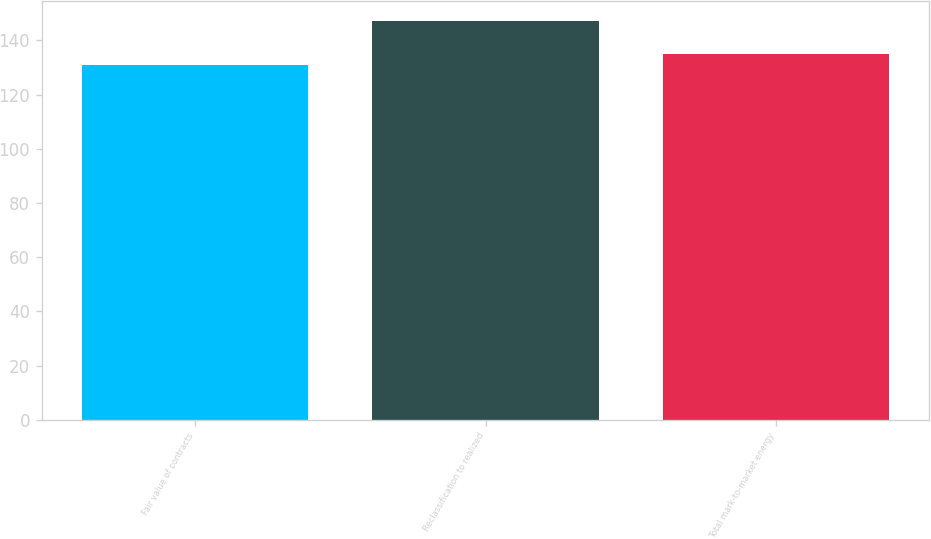<chart> <loc_0><loc_0><loc_500><loc_500><bar_chart><fcel>Fair value of contracts<fcel>Reclassification to realized<fcel>Total mark-to-market energy<nl><fcel>131<fcel>147<fcel>134.8<nl></chart> 